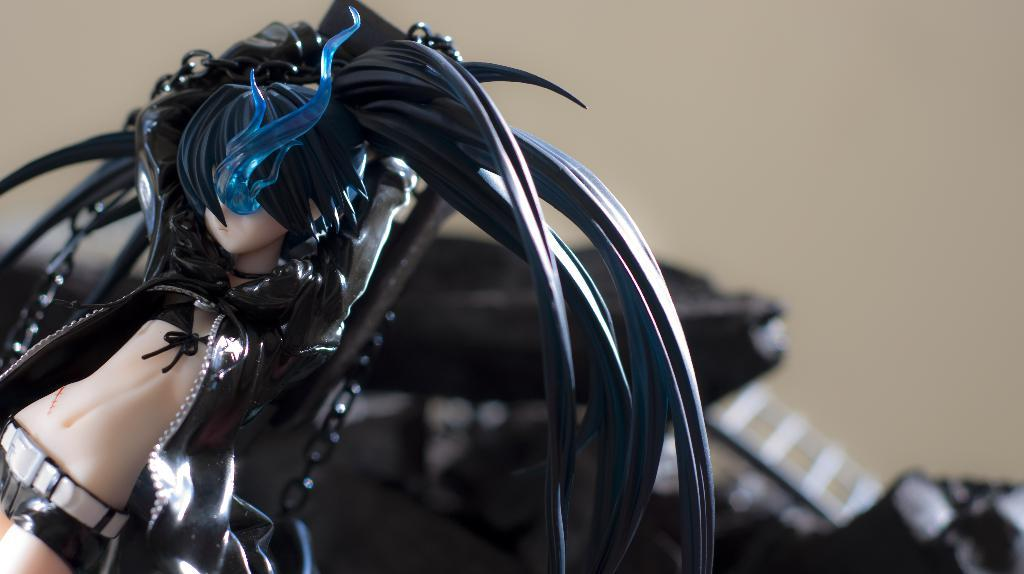What is the main object in the image? There is a toy in the image. Can you describe the colors of the toy? The toy has cream, black, white, and blue colors. What can be seen in the background of the image? There are black objects in the background of the image. What color is the wall in the background? The wall in the background is cream colored. How many potatoes are being used in the war depicted in the image? There is no war or potatoes present in the image; it features a toy with various colors and a cream-colored wall in the background. 